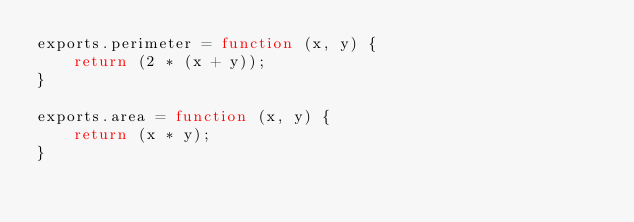Convert code to text. <code><loc_0><loc_0><loc_500><loc_500><_JavaScript_>exports.perimeter = function (x, y) {
    return (2 * (x + y));
}

exports.area = function (x, y) {
    return (x * y);
}</code> 